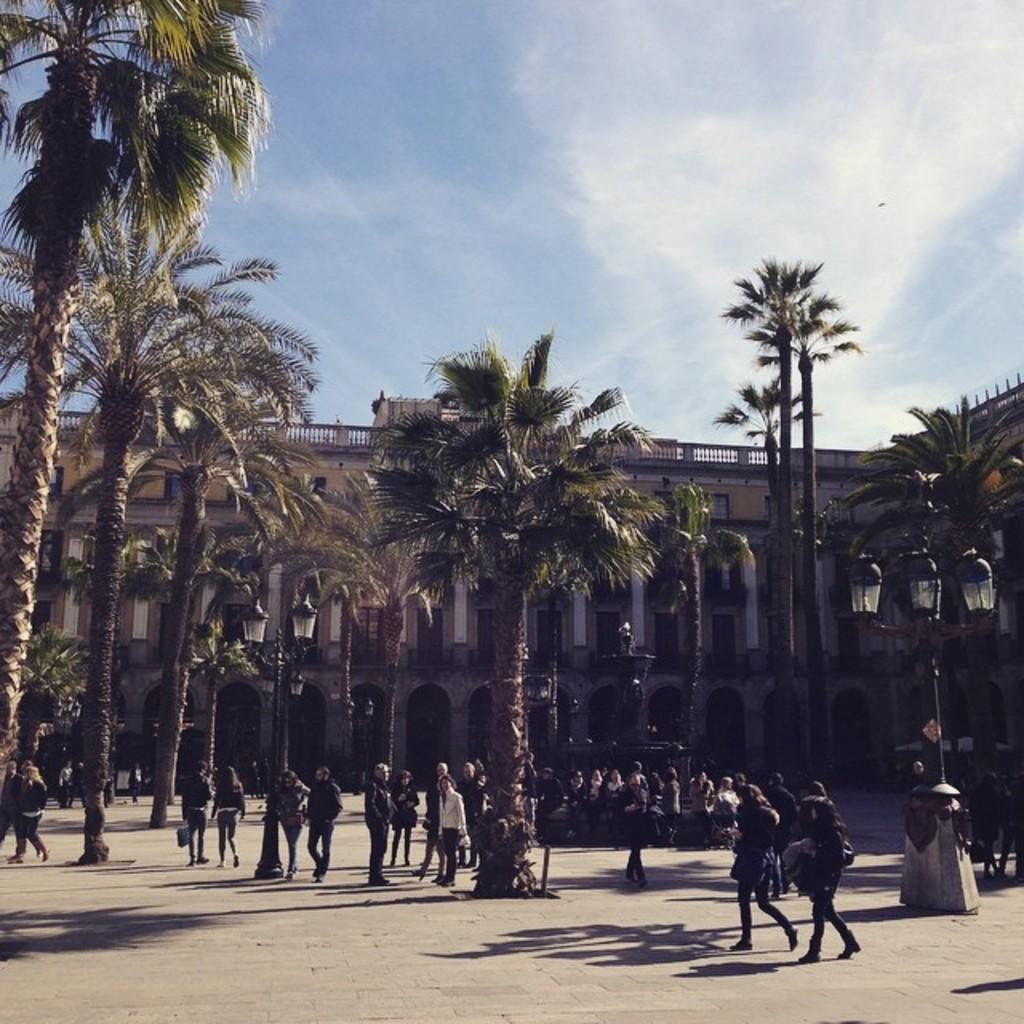In one or two sentences, can you explain what this image depicts? In the picture we can see a path surface on it, we can see people are walking and some are standing and talking to each other and near to them, we can see some trees which are tall and in the background we can see a building and behind it we can see the sky with clouds. 